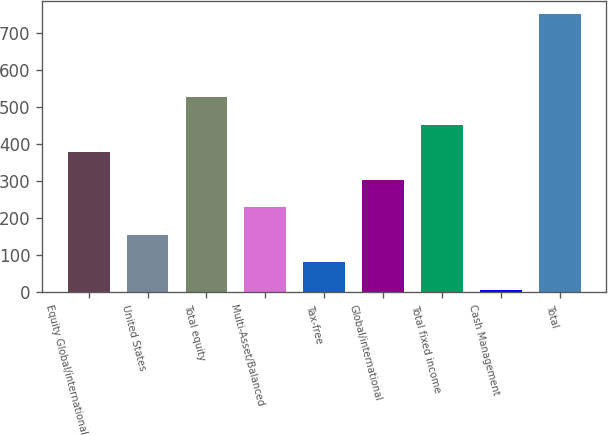Convert chart to OTSL. <chart><loc_0><loc_0><loc_500><loc_500><bar_chart><fcel>Equity Global/international<fcel>United States<fcel>Total equity<fcel>Multi-Asset/Balanced<fcel>Tax-free<fcel>Global/international<fcel>Total fixed income<fcel>Cash Management<fcel>Total<nl><fcel>377.9<fcel>155.06<fcel>526.46<fcel>229.34<fcel>80.78<fcel>303.62<fcel>452.18<fcel>6.5<fcel>749.3<nl></chart> 